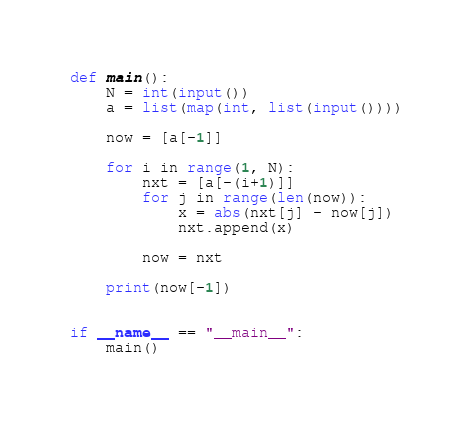<code> <loc_0><loc_0><loc_500><loc_500><_Python_>def main():
    N = int(input())
    a = list(map(int, list(input())))

    now = [a[-1]]

    for i in range(1, N):
        nxt = [a[-(i+1)]]
        for j in range(len(now)):
            x = abs(nxt[j] - now[j])
            nxt.append(x)

        now = nxt

    print(now[-1])


if __name__ == "__main__":
    main()
</code> 